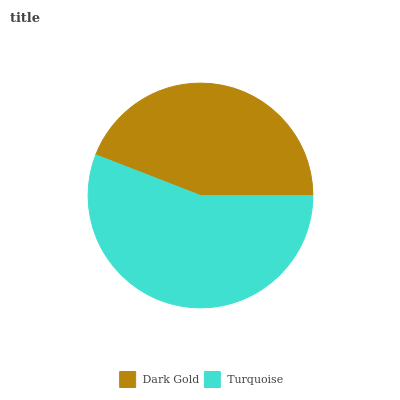Is Dark Gold the minimum?
Answer yes or no. Yes. Is Turquoise the maximum?
Answer yes or no. Yes. Is Turquoise the minimum?
Answer yes or no. No. Is Turquoise greater than Dark Gold?
Answer yes or no. Yes. Is Dark Gold less than Turquoise?
Answer yes or no. Yes. Is Dark Gold greater than Turquoise?
Answer yes or no. No. Is Turquoise less than Dark Gold?
Answer yes or no. No. Is Turquoise the high median?
Answer yes or no. Yes. Is Dark Gold the low median?
Answer yes or no. Yes. Is Dark Gold the high median?
Answer yes or no. No. Is Turquoise the low median?
Answer yes or no. No. 